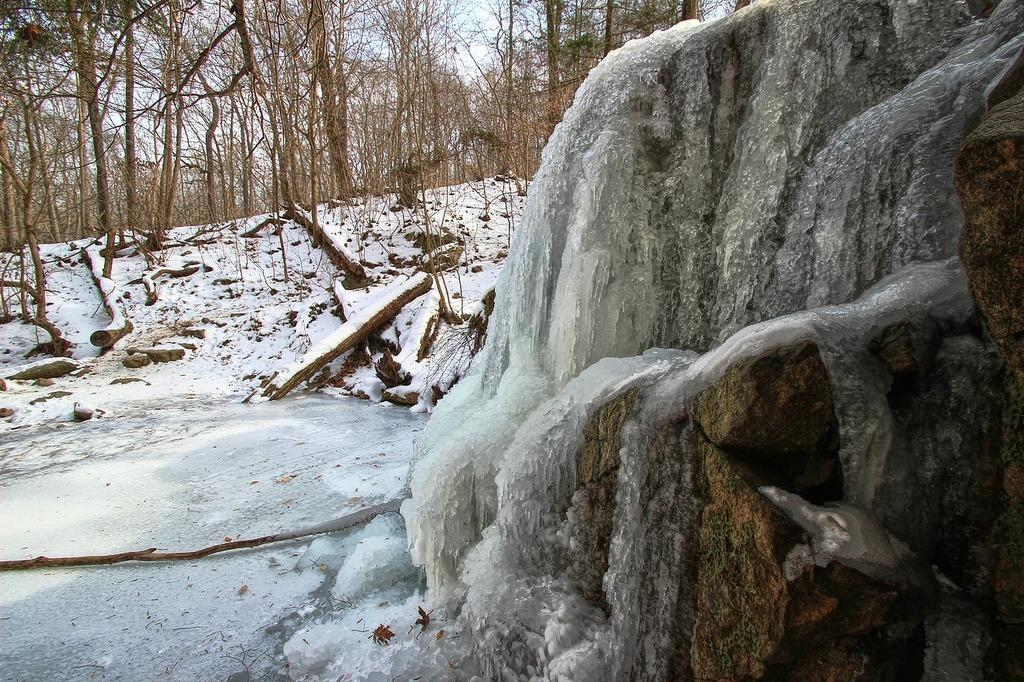What type of vegetation is present in the image? There are trees in the image. What can be found on the ground in the image? There are wooden objects on the ground. What is located on the right side of the image? There are rocks and snow on the right side of the image. What is visible in the background of the image? The sky is visible in the background of the image. Can you describe the digestion process of the goat in the image? There is no goat present in the image, so we cannot describe its digestion process. What type of carriage is being pulled by the horses in the image? There are no horses or carriages present in the image. 